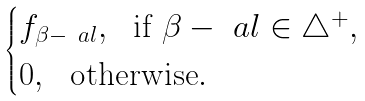Convert formula to latex. <formula><loc_0><loc_0><loc_500><loc_500>\begin{cases} f _ { \beta - \ a l } , \ \text { if } \beta - \ a l \in \triangle ^ { + } , \\ 0 , \ \text { otherwise} . \end{cases}</formula> 